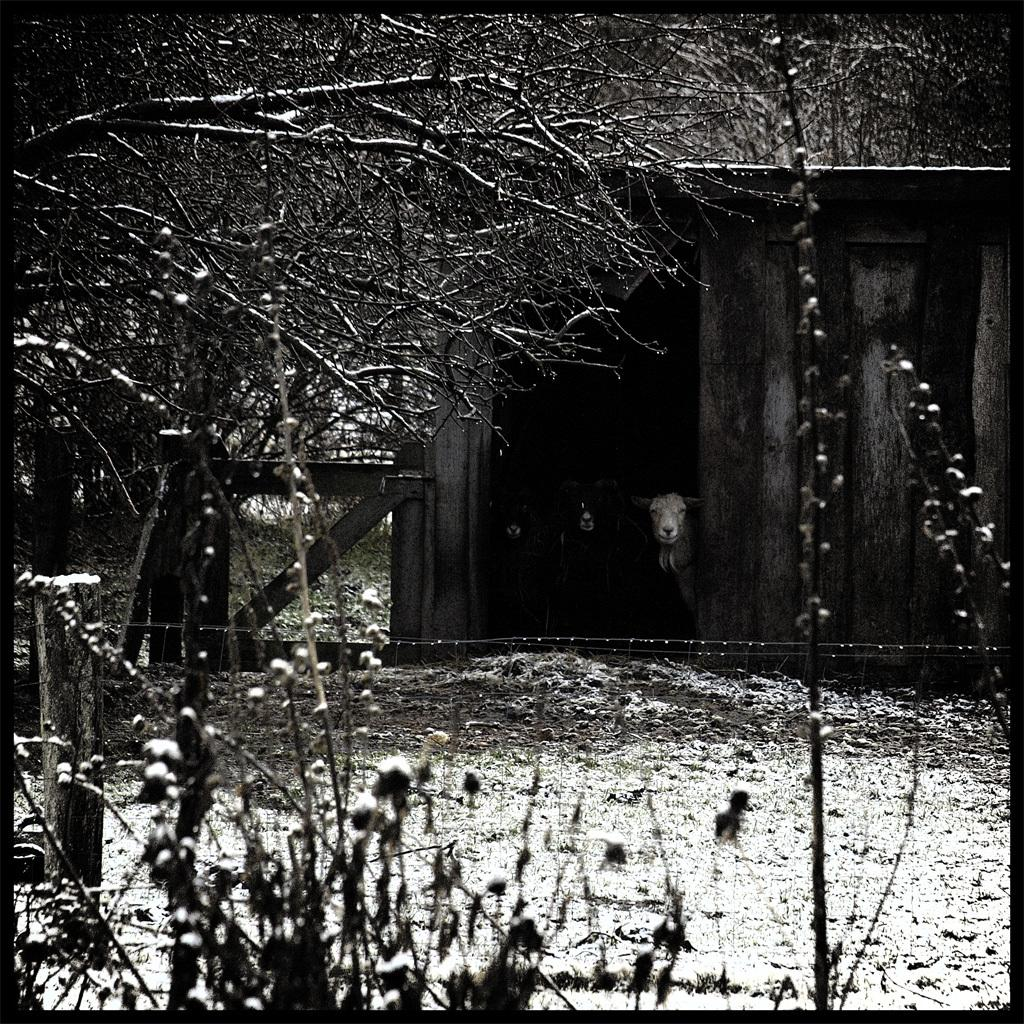What is the color scheme of the image? The image is black and white. What types of living organisms are present in the image? There are animals and plants in the image. What type of vegetation can be seen in the image? There are trees in the image. What structure is present for the animals? There is a house for animals in the image. Where is the lunchroom located in the image? There is no lunchroom present in the image. Can you describe the arch in the image? There is no arch present in the image. 